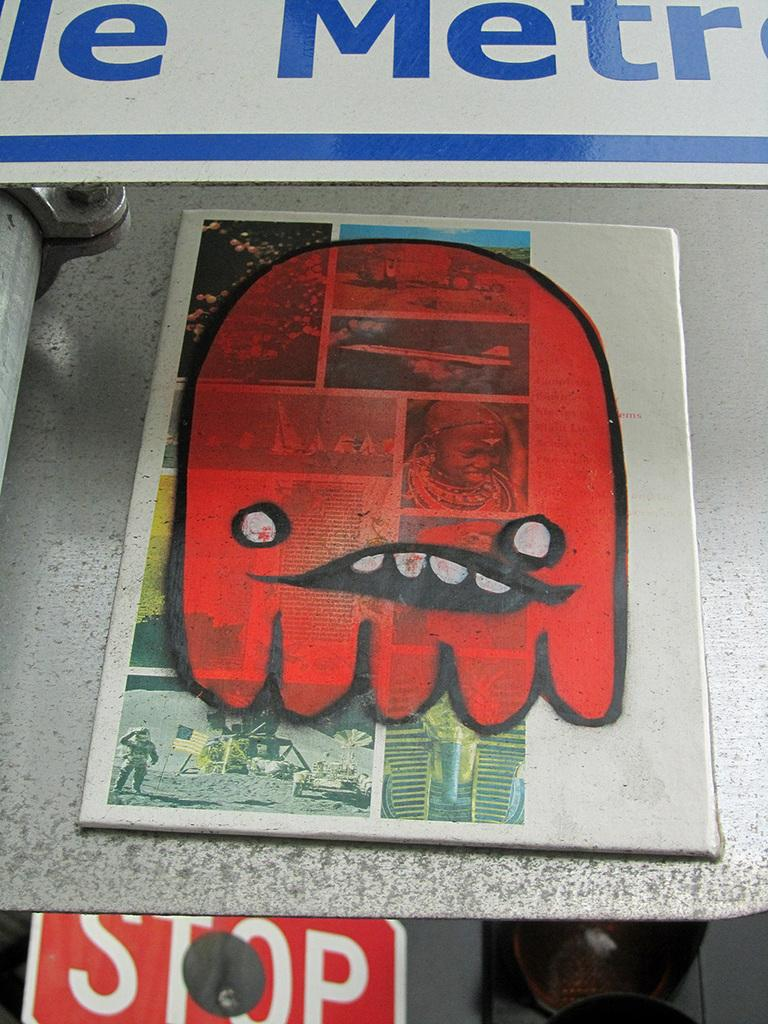Provide a one-sentence caption for the provided image. a red figure above a stop sign on a paper. 